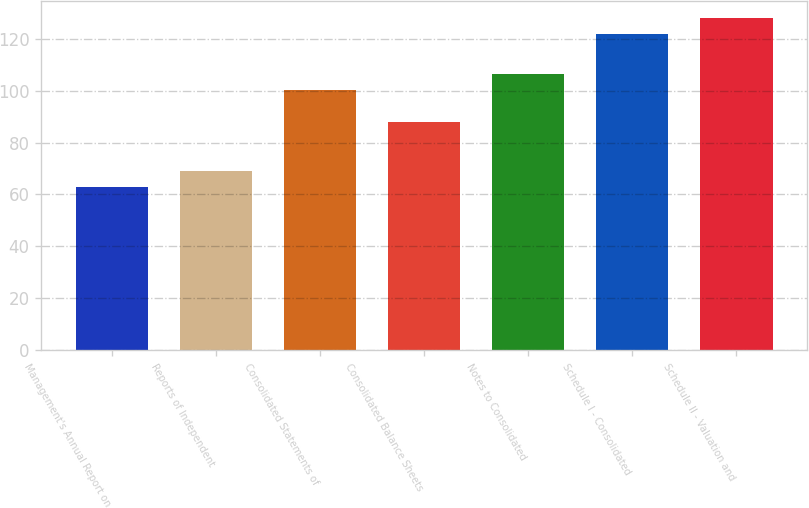<chart> <loc_0><loc_0><loc_500><loc_500><bar_chart><fcel>Management's Annual Report on<fcel>Reports of Independent<fcel>Consolidated Statements of<fcel>Consolidated Balance Sheets<fcel>Notes to Consolidated<fcel>Schedule I - Consolidated<fcel>Schedule II - Valuation and<nl><fcel>63<fcel>69.2<fcel>100.2<fcel>87.8<fcel>106.4<fcel>122<fcel>128.2<nl></chart> 